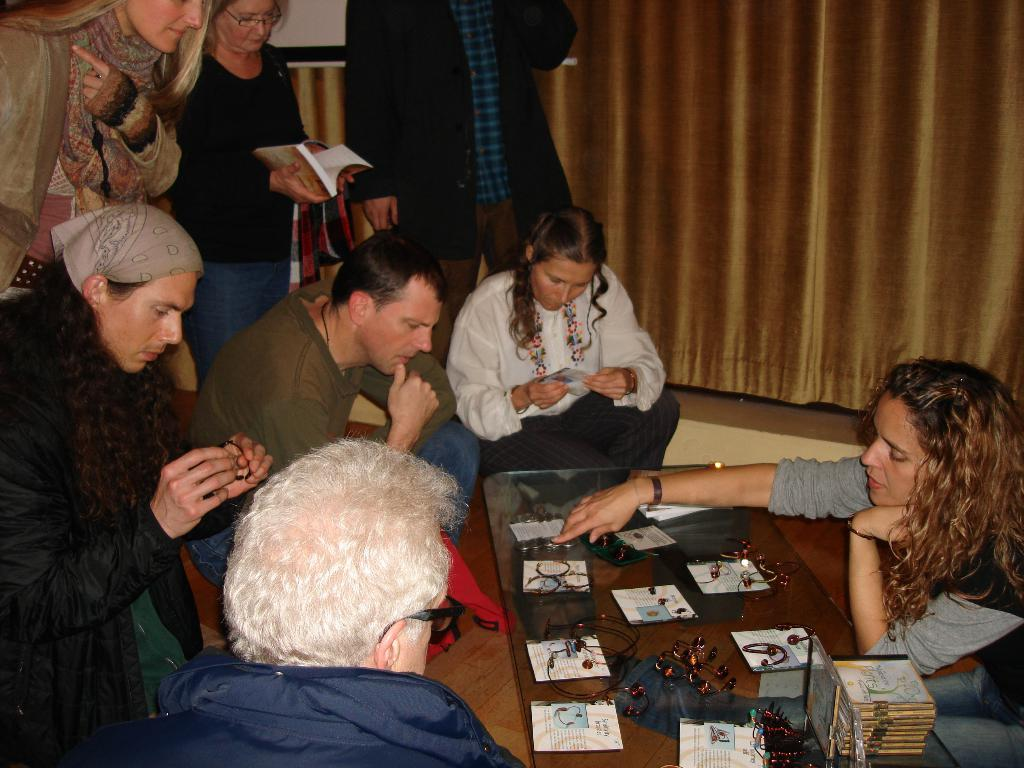What are the people in the image doing? There are people sitting and standing in the image. Can you describe the background of the image? There is a golden color curtain in the background of the image. What type of loaf can be seen on the table in the image? There is no table or loaf present in the image. How does the bottle affect the acoustics in the image? There is no bottle or mention of acoustics in the image. 